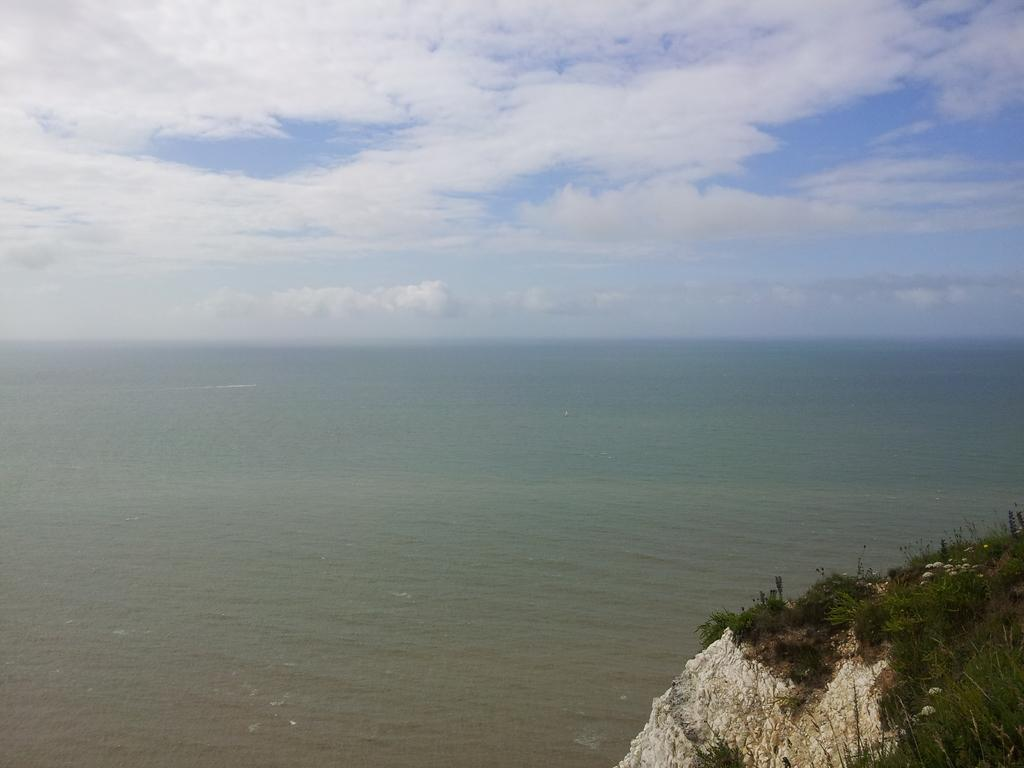What is the main element present in the image? There is water in the image. What can be seen in the bottom right of the image? There are rock mountains in the bottom right of the image. What type of vegetation is present on the rock mountains? There are plants on the rock mountains. What type of ground cover is present on the rock mountains? There is grass on the rock mountains. What is visible at the top of the image? The sky is visible at the top of the image. What type of wool is being spun on the floor in the image? There is no wool or spinning activity present in the image; it features water, rock mountains, plants, and grass. 